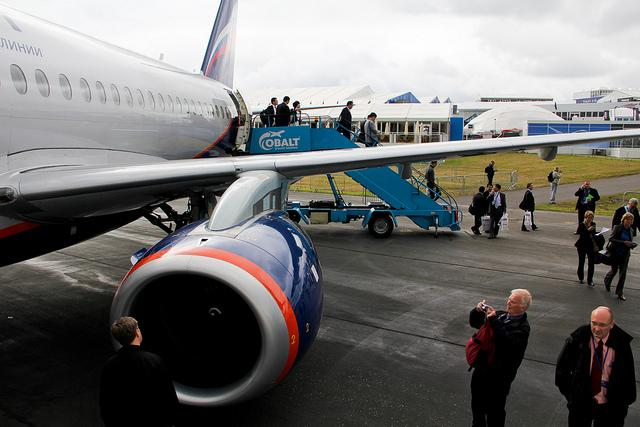What is the man with the red backpack on the right doing? taking photo 